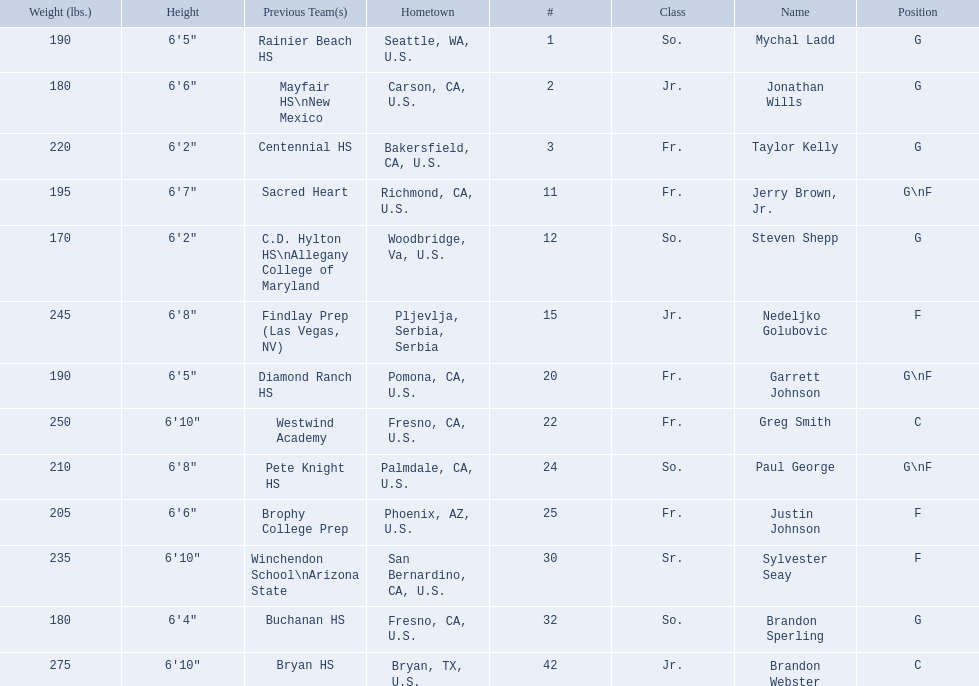Who are all the players in the 2009-10 fresno state bulldogs men's basketball team? Mychal Ladd, Jonathan Wills, Taylor Kelly, Jerry Brown, Jr., Steven Shepp, Nedeljko Golubovic, Garrett Johnson, Greg Smith, Paul George, Justin Johnson, Sylvester Seay, Brandon Sperling, Brandon Webster. Of these players, who are the ones who play forward? Jerry Brown, Jr., Nedeljko Golubovic, Garrett Johnson, Paul George, Justin Johnson, Sylvester Seay. Of these players, which ones only play forward and no other position? Nedeljko Golubovic, Justin Johnson, Sylvester Seay. Of these players, who is the shortest? Justin Johnson. 